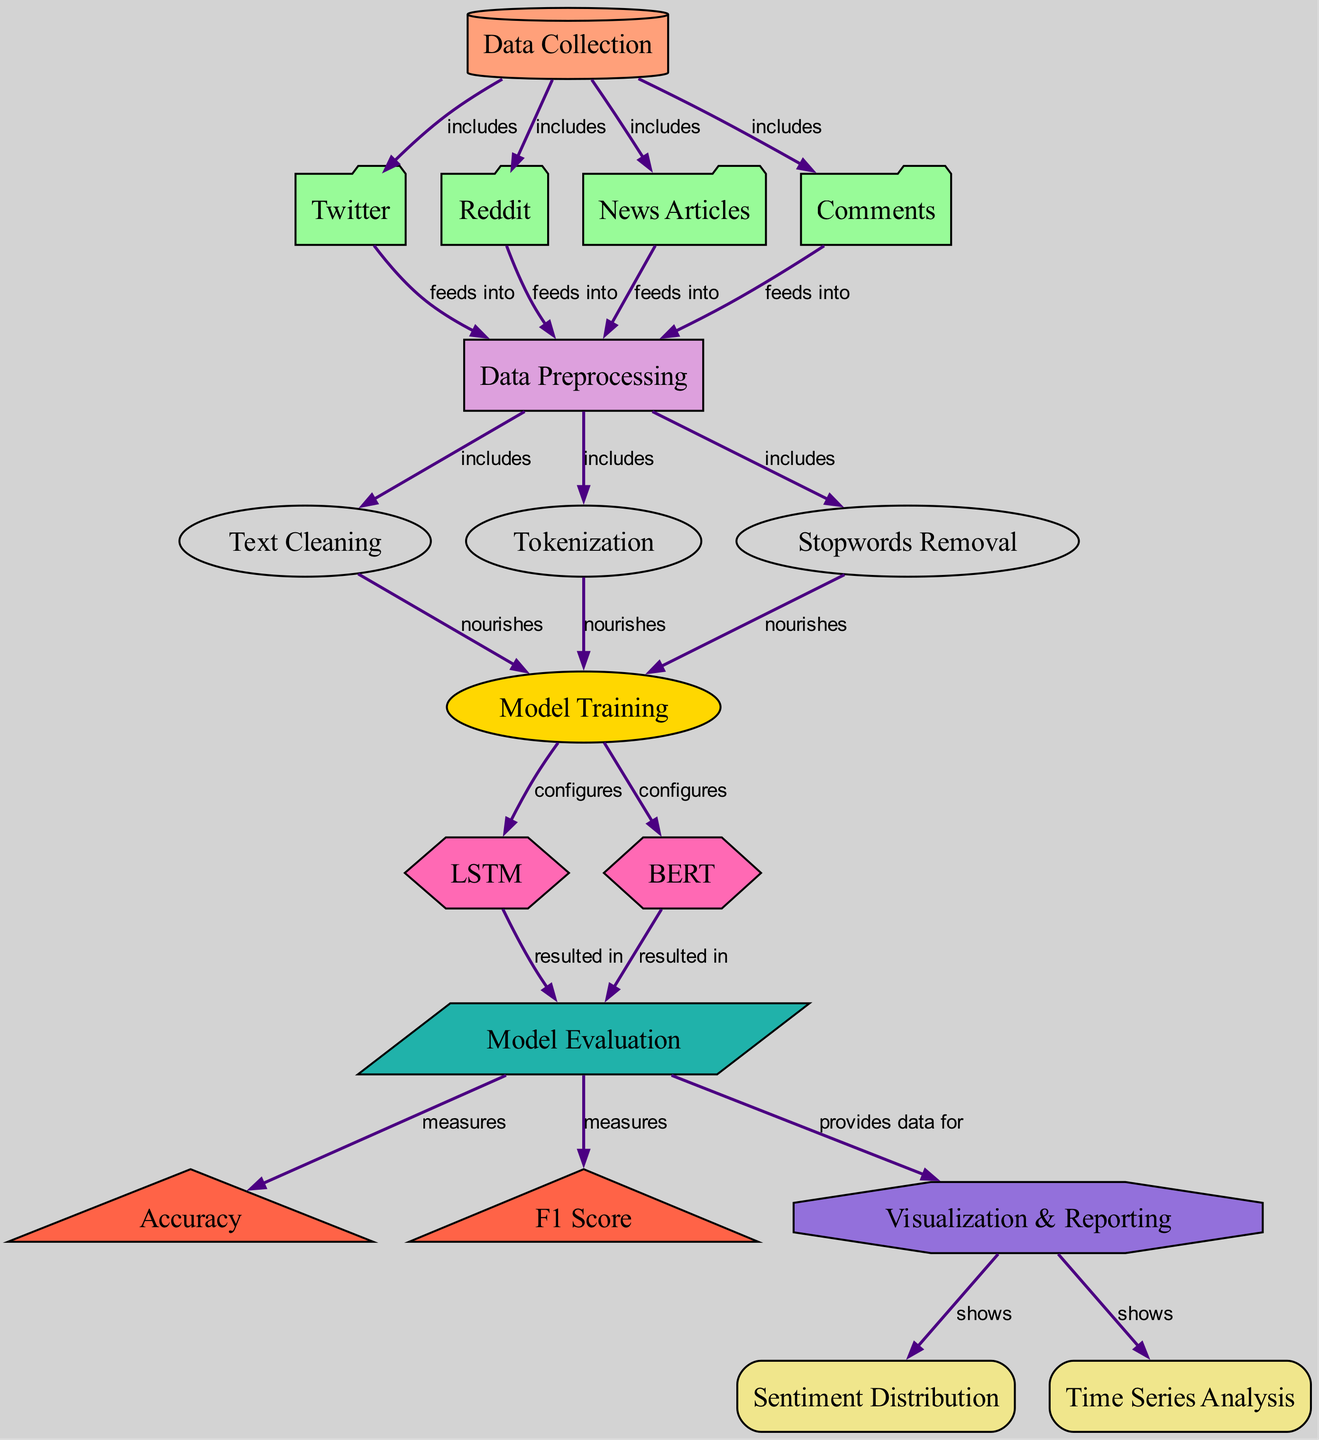What are the sources of data collection? The diagram shows four sources of data collection: Twitter, Reddit, News Articles, and Comments. Each of these is explicitly labeled under the data collection node, indicating that they are the types of public opinion data included in the analysis.
Answer: Twitter, Reddit, News Articles, Comments What occurs immediately after data collection? According to the diagram, after data collection, the next step is data preprocessing. This indicates that the raw data collected from the sources will be processed to clean and prepare it for analysis.
Answer: Data Preprocessing How many preprocessing steps are included in the data preprocessing? The diagram specifies three preprocessing steps: Text Cleaning, Tokenization, and Stopwords Removal. Each of these steps is shown as a direct part of the data preprocessing node.
Answer: Three Which model configurations are used for training? The diagram displays two models used for training: LSTM and BERT. Both of these models are directly connected to the Model Training node, indicating that these configurations are utilized in the analysis.
Answer: LSTM, BERT What metrics are measured during model evaluation? The diagram illustrates that Accuracy and F1 Score are the metrics measured during model evaluation. These metrics are directly linked to the Model Evaluation node, highlighting their importance in assessing the model's performance.
Answer: Accuracy, F1 Score What kind of analysis is shown in the visualization node? The visualization node shows two types of analysis: Sentiment Distribution and Time Series Analysis. This indicates the aspects of the sentiment analysis that will be reported visually following the model evaluation.
Answer: Sentiment Distribution, Time Series Analysis Which step directly nourishes the model training process? The diagram indicates that Text Cleaning, Tokenization, and Stopwords Removal all nourish the Model Training step. This means that these preprocessing steps provide the necessary data input for training the models.
Answer: Text Cleaning, Tokenization, Stopwords Removal How does the evaluation model contribute to visualization? The Model Evaluation node provides data for the Visualization & Reporting step, signifying that the results from the evaluation metrics directly inform the visual representation of the analysis findings.
Answer: Provides data for Visualization & Reporting What type of diagram is represented in this system? The diagram represents a Machine Learning Diagram, which outlines the steps involved in performing sentiment analysis on public opinion about prisoner rights advocacies, from data collection to visualization.
Answer: Machine Learning Diagram 